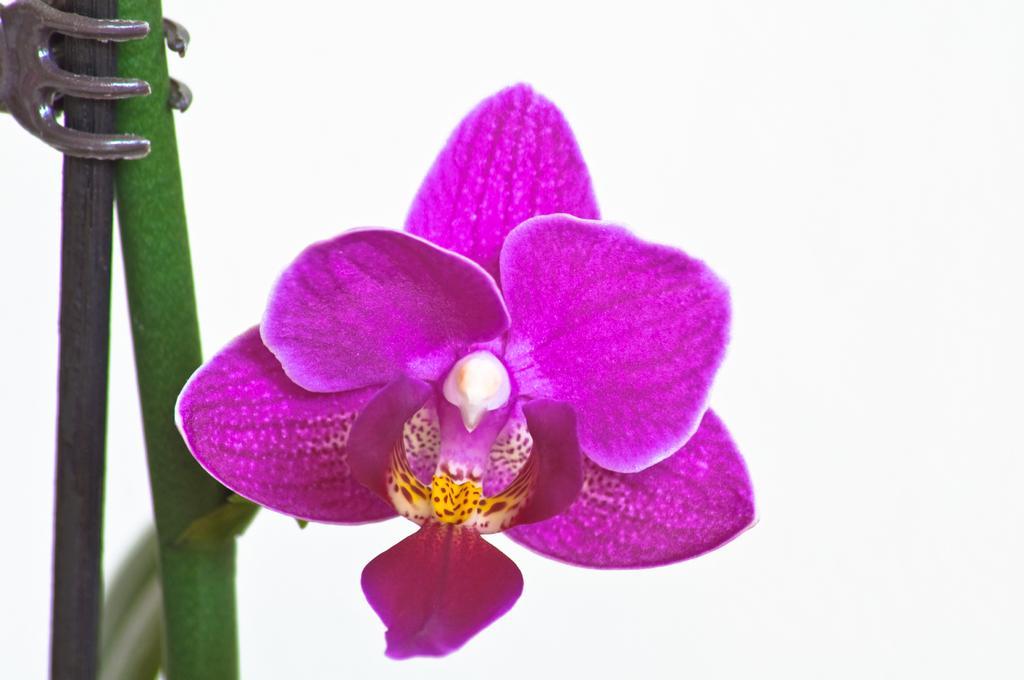Please provide a concise description of this image. In the image I can see a flower which is to the stem and it is in purple color. 